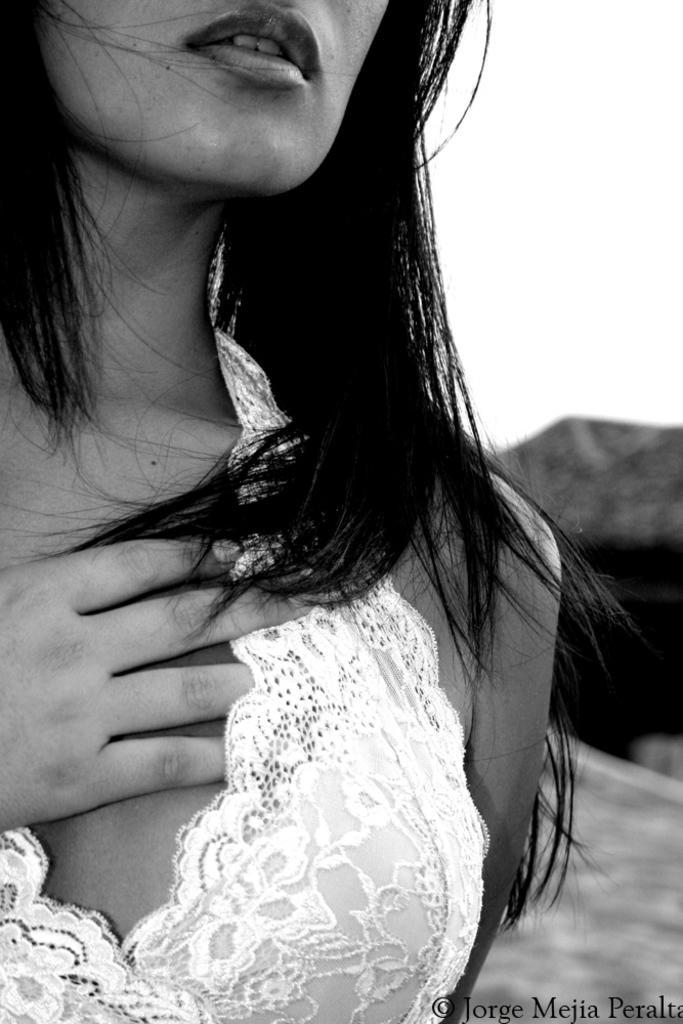Can you describe this image briefly? In this picture we can see a woman, there is a blurry background, we can see some text at the right bottom. 